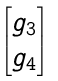Convert formula to latex. <formula><loc_0><loc_0><loc_500><loc_500>\begin{bmatrix} g _ { 3 } \\ g _ { 4 } \end{bmatrix}</formula> 